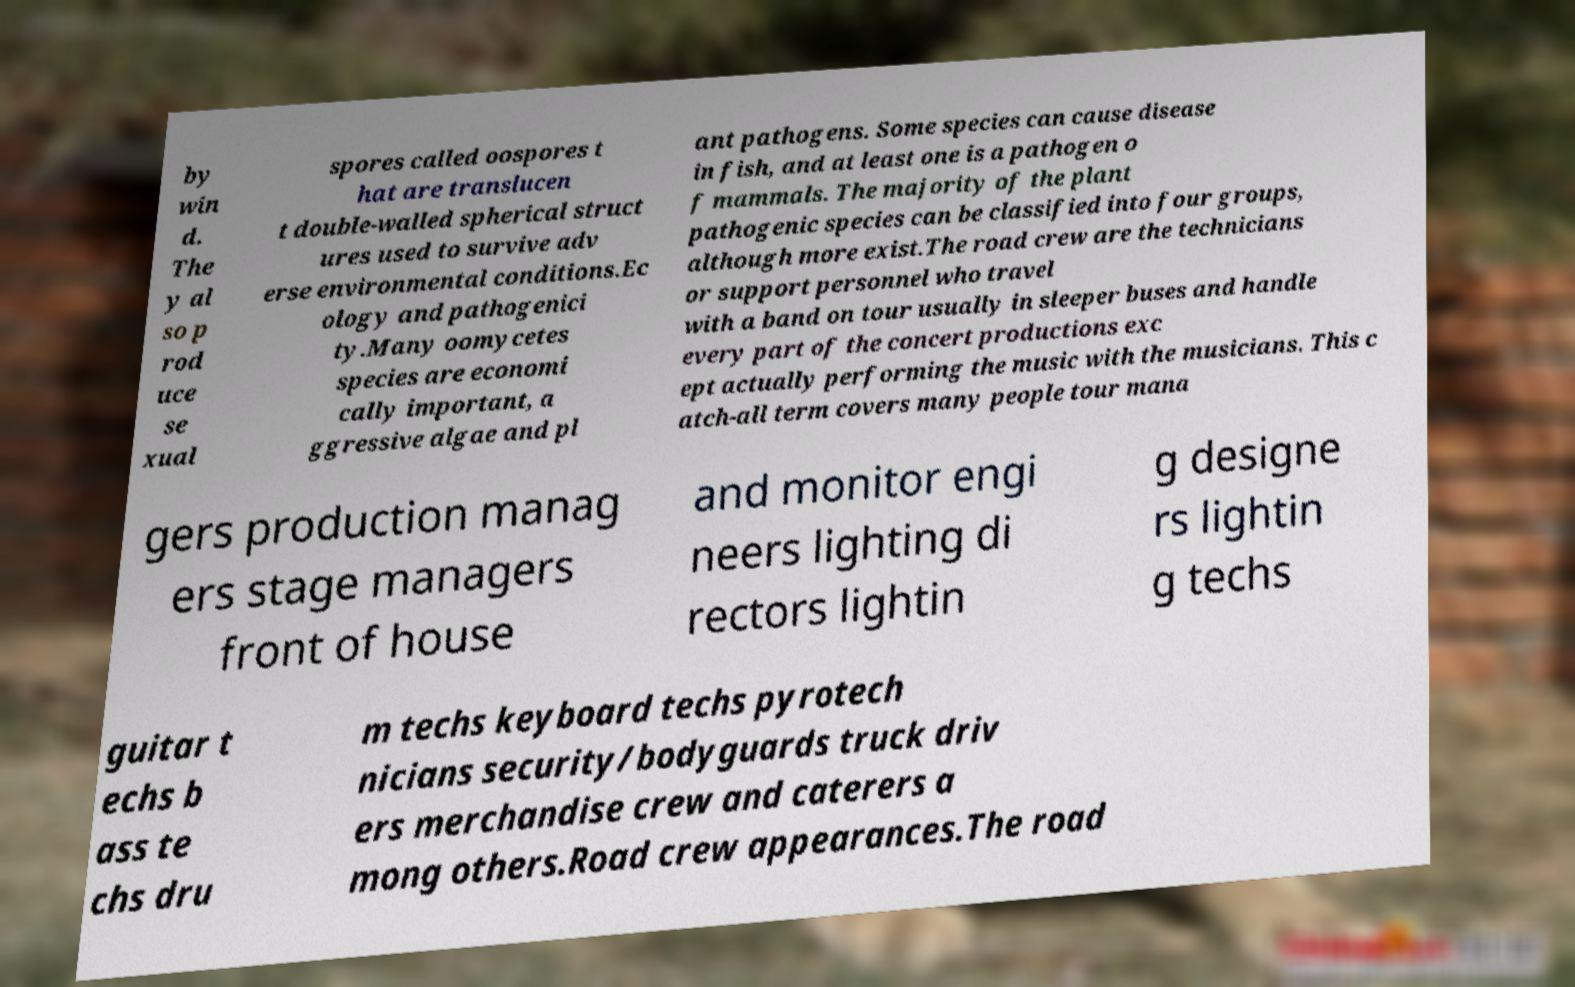Please identify and transcribe the text found in this image. by win d. The y al so p rod uce se xual spores called oospores t hat are translucen t double-walled spherical struct ures used to survive adv erse environmental conditions.Ec ology and pathogenici ty.Many oomycetes species are economi cally important, a ggressive algae and pl ant pathogens. Some species can cause disease in fish, and at least one is a pathogen o f mammals. The majority of the plant pathogenic species can be classified into four groups, although more exist.The road crew are the technicians or support personnel who travel with a band on tour usually in sleeper buses and handle every part of the concert productions exc ept actually performing the music with the musicians. This c atch-all term covers many people tour mana gers production manag ers stage managers front of house and monitor engi neers lighting di rectors lightin g designe rs lightin g techs guitar t echs b ass te chs dru m techs keyboard techs pyrotech nicians security/bodyguards truck driv ers merchandise crew and caterers a mong others.Road crew appearances.The road 